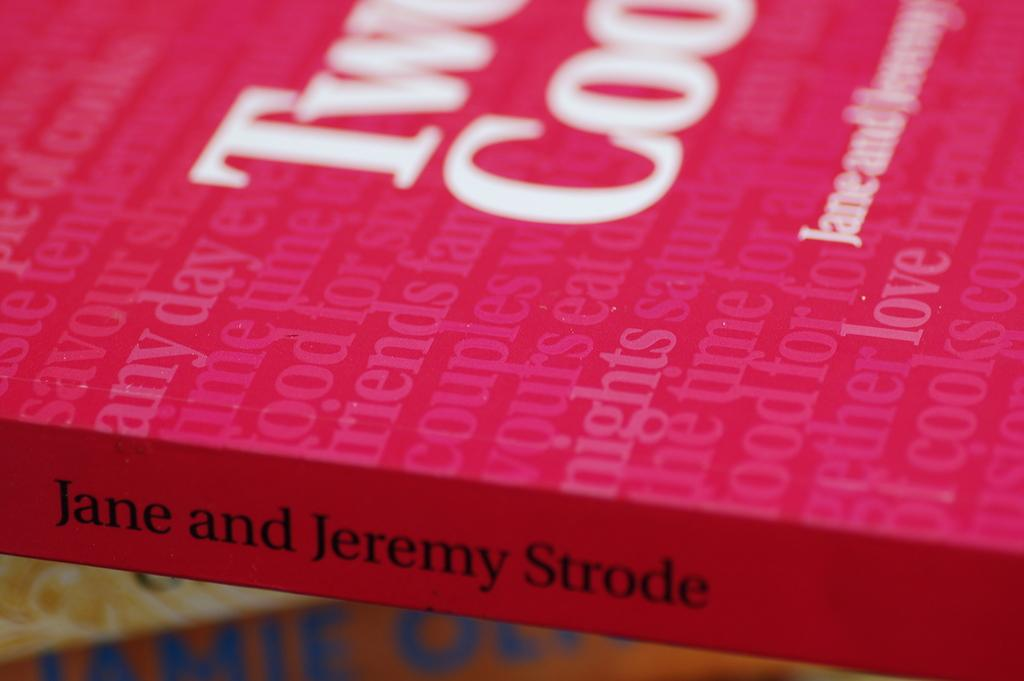<image>
Summarize the visual content of the image. An up close shot of a  book written by Jane and Jeremy Strode. 